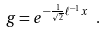Convert formula to latex. <formula><loc_0><loc_0><loc_500><loc_500>g = e ^ { - { \frac { 1 } { \sqrt { 2 } } } \ell ^ { - 1 } x } \text { } .</formula> 